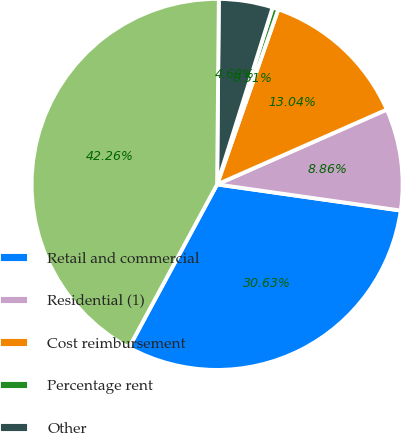<chart> <loc_0><loc_0><loc_500><loc_500><pie_chart><fcel>Retail and commercial<fcel>Residential (1)<fcel>Cost reimbursement<fcel>Percentage rent<fcel>Other<fcel>Total rental income<nl><fcel>30.63%<fcel>8.86%<fcel>13.04%<fcel>0.51%<fcel>4.69%<fcel>42.26%<nl></chart> 